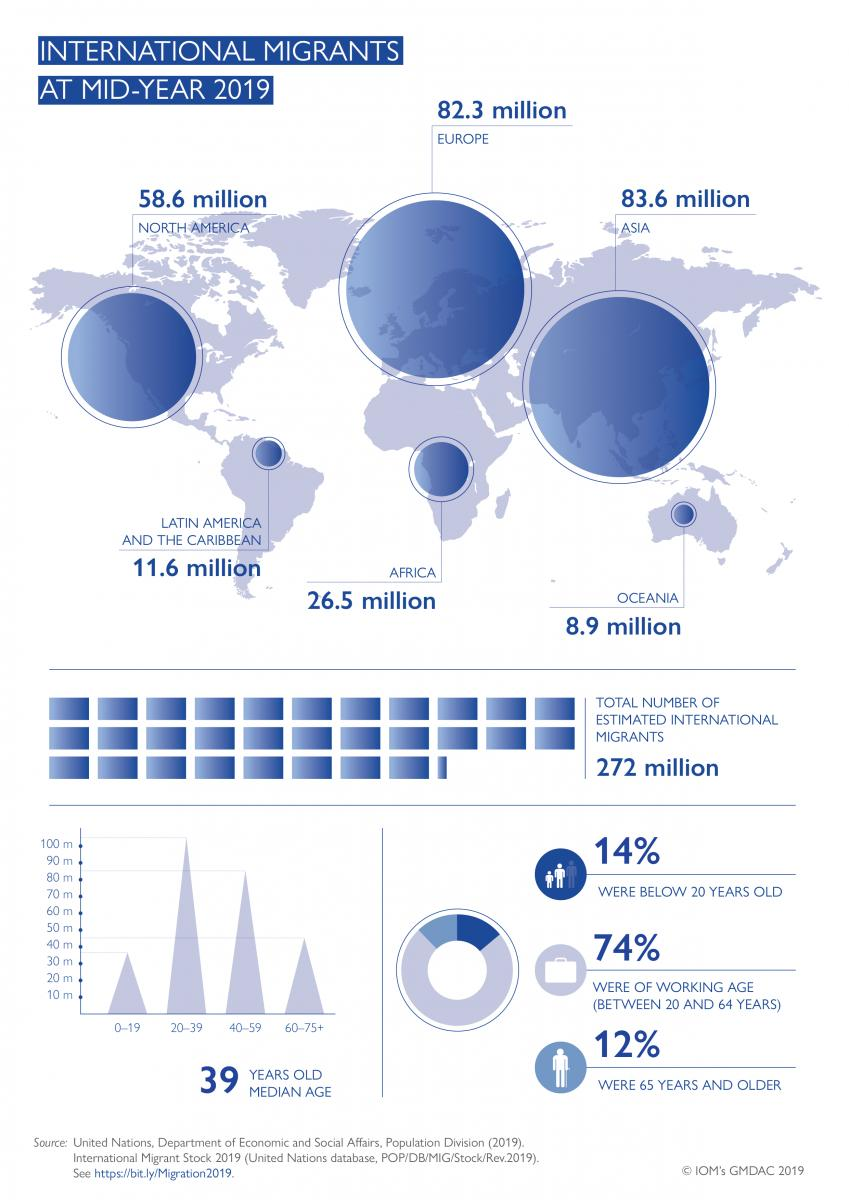Give some essential details in this illustration. As of mid-year 2019, the total number of migrants in North America, Latin America, and the Caribbean was approximately 70.2 million. The second largest age group among migrants is 40-59 years old. According to the data from mid-year 2019, the total number of migrants in Oceania and Europe was estimated to be 91.2 million. At mid-year 2019, the total number of migrants in North America and Europe was estimated to be 140.9 million. The third largest age group among migrants is 60-75 years old and above. 